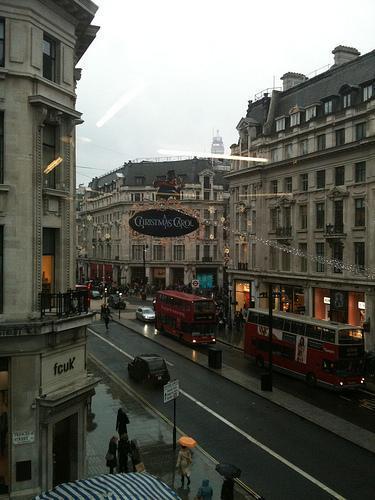How many people are carrying umbrellas?
Give a very brief answer. 2. How many buses are there?
Give a very brief answer. 2. How many double decker busses are shown?
Give a very brief answer. 2. 